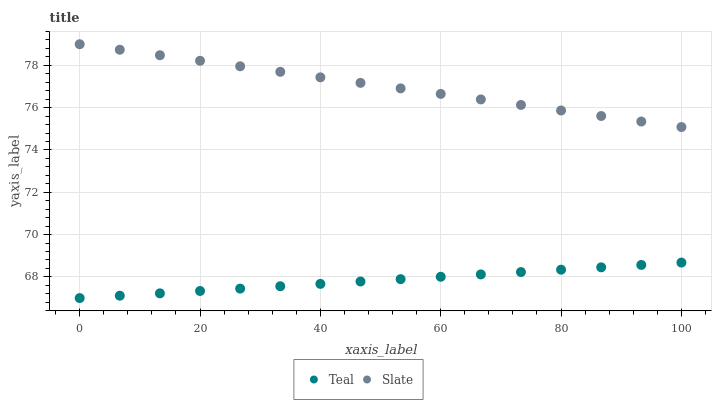Does Teal have the minimum area under the curve?
Answer yes or no. Yes. Does Slate have the maximum area under the curve?
Answer yes or no. Yes. Does Teal have the maximum area under the curve?
Answer yes or no. No. Is Slate the smoothest?
Answer yes or no. Yes. Is Teal the roughest?
Answer yes or no. Yes. Is Teal the smoothest?
Answer yes or no. No. Does Teal have the lowest value?
Answer yes or no. Yes. Does Slate have the highest value?
Answer yes or no. Yes. Does Teal have the highest value?
Answer yes or no. No. Is Teal less than Slate?
Answer yes or no. Yes. Is Slate greater than Teal?
Answer yes or no. Yes. Does Teal intersect Slate?
Answer yes or no. No. 